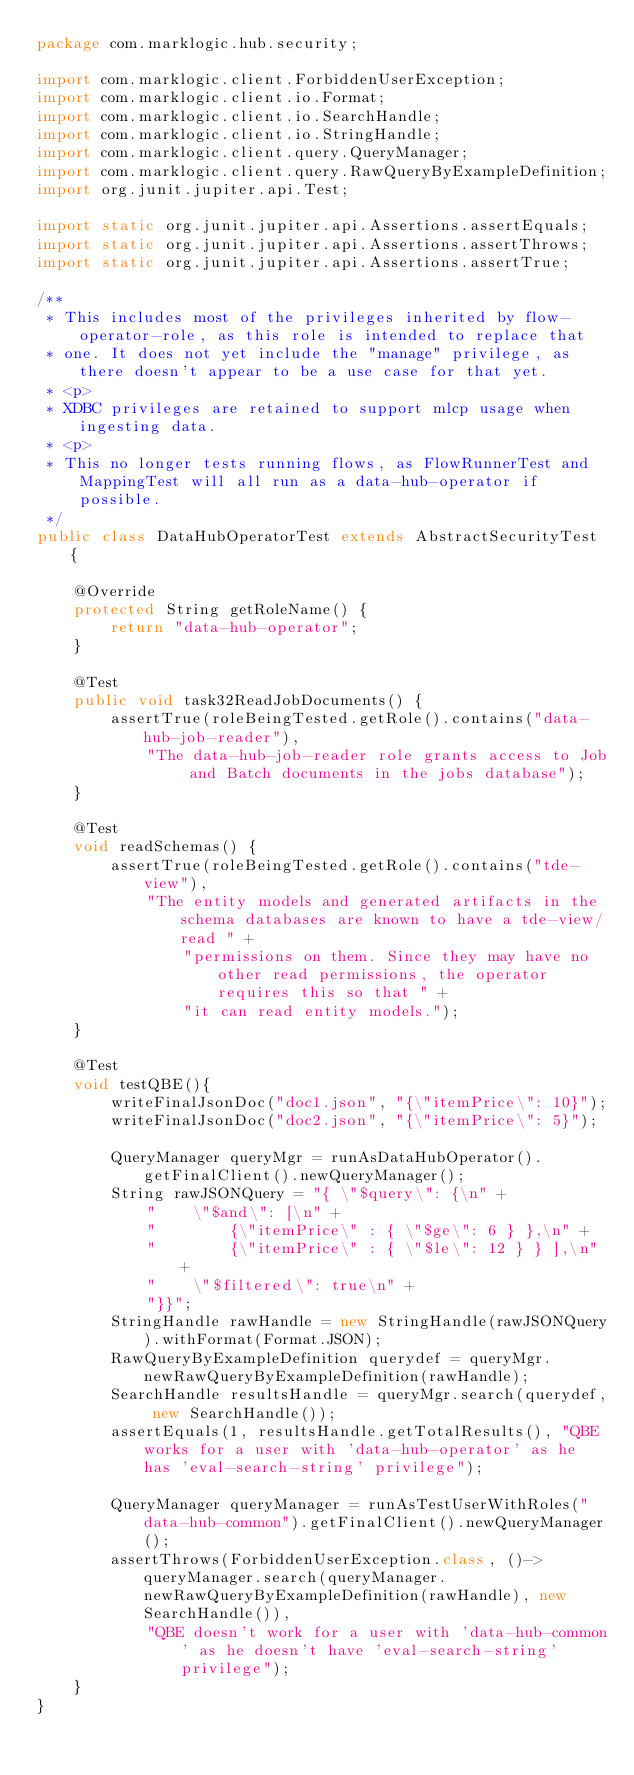Convert code to text. <code><loc_0><loc_0><loc_500><loc_500><_Java_>package com.marklogic.hub.security;

import com.marklogic.client.ForbiddenUserException;
import com.marklogic.client.io.Format;
import com.marklogic.client.io.SearchHandle;
import com.marklogic.client.io.StringHandle;
import com.marklogic.client.query.QueryManager;
import com.marklogic.client.query.RawQueryByExampleDefinition;
import org.junit.jupiter.api.Test;

import static org.junit.jupiter.api.Assertions.assertEquals;
import static org.junit.jupiter.api.Assertions.assertThrows;
import static org.junit.jupiter.api.Assertions.assertTrue;

/**
 * This includes most of the privileges inherited by flow-operator-role, as this role is intended to replace that
 * one. It does not yet include the "manage" privilege, as there doesn't appear to be a use case for that yet.
 * <p>
 * XDBC privileges are retained to support mlcp usage when ingesting data.
 * <p>
 * This no longer tests running flows, as FlowRunnerTest and MappingTest will all run as a data-hub-operator if possible.
 */
public class DataHubOperatorTest extends AbstractSecurityTest {

    @Override
    protected String getRoleName() {
        return "data-hub-operator";
    }

    @Test
    public void task32ReadJobDocuments() {
        assertTrue(roleBeingTested.getRole().contains("data-hub-job-reader"),
            "The data-hub-job-reader role grants access to Job and Batch documents in the jobs database");
    }

    @Test
    void readSchemas() {
        assertTrue(roleBeingTested.getRole().contains("tde-view"),
            "The entity models and generated artifacts in the schema databases are known to have a tde-view/read " +
                "permissions on them. Since they may have no other read permissions, the operator requires this so that " +
                "it can read entity models.");
    }

    @Test
    void testQBE(){
        writeFinalJsonDoc("doc1.json", "{\"itemPrice\": 10}");
        writeFinalJsonDoc("doc2.json", "{\"itemPrice\": 5}");

        QueryManager queryMgr = runAsDataHubOperator().getFinalClient().newQueryManager();
        String rawJSONQuery = "{ \"$query\": {\n" +
            "    \"$and\": [\n" +
            "        {\"itemPrice\" : { \"$ge\": 6 } },\n" +
            "        {\"itemPrice\" : { \"$le\": 12 } } ],\n" +
            "    \"$filtered\": true\n" +
            "}}";
        StringHandle rawHandle = new StringHandle(rawJSONQuery).withFormat(Format.JSON);
        RawQueryByExampleDefinition querydef = queryMgr.newRawQueryByExampleDefinition(rawHandle);
        SearchHandle resultsHandle = queryMgr.search(querydef, new SearchHandle());
        assertEquals(1, resultsHandle.getTotalResults(), "QBE works for a user with 'data-hub-operator' as he has 'eval-search-string' privilege");

        QueryManager queryManager = runAsTestUserWithRoles("data-hub-common").getFinalClient().newQueryManager();
        assertThrows(ForbiddenUserException.class, ()->queryManager.search(queryManager.newRawQueryByExampleDefinition(rawHandle), new SearchHandle()),
            "QBE doesn't work for a user with 'data-hub-common' as he doesn't have 'eval-search-string' privilege");
    }
}
</code> 